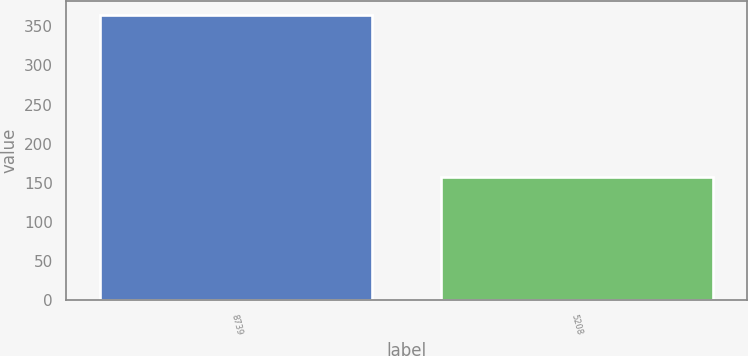Convert chart to OTSL. <chart><loc_0><loc_0><loc_500><loc_500><bar_chart><fcel>8739<fcel>5208<nl><fcel>364.5<fcel>158<nl></chart> 